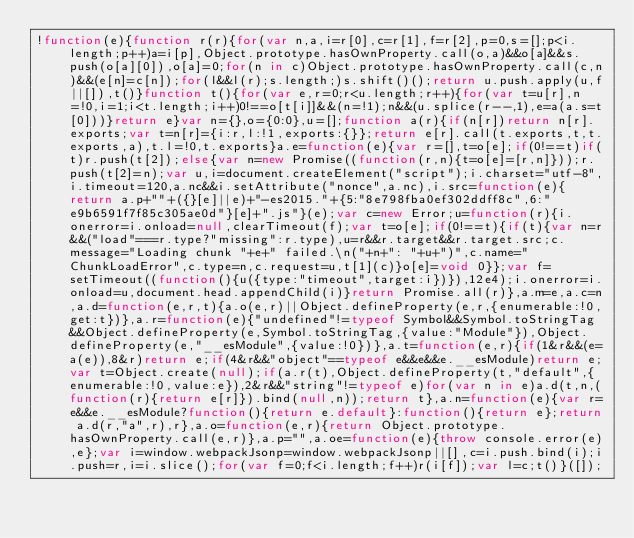<code> <loc_0><loc_0><loc_500><loc_500><_JavaScript_>!function(e){function r(r){for(var n,a,i=r[0],c=r[1],f=r[2],p=0,s=[];p<i.length;p++)a=i[p],Object.prototype.hasOwnProperty.call(o,a)&&o[a]&&s.push(o[a][0]),o[a]=0;for(n in c)Object.prototype.hasOwnProperty.call(c,n)&&(e[n]=c[n]);for(l&&l(r);s.length;)s.shift()();return u.push.apply(u,f||[]),t()}function t(){for(var e,r=0;r<u.length;r++){for(var t=u[r],n=!0,i=1;i<t.length;i++)0!==o[t[i]]&&(n=!1);n&&(u.splice(r--,1),e=a(a.s=t[0]))}return e}var n={},o={0:0},u=[];function a(r){if(n[r])return n[r].exports;var t=n[r]={i:r,l:!1,exports:{}};return e[r].call(t.exports,t,t.exports,a),t.l=!0,t.exports}a.e=function(e){var r=[],t=o[e];if(0!==t)if(t)r.push(t[2]);else{var n=new Promise((function(r,n){t=o[e]=[r,n]}));r.push(t[2]=n);var u,i=document.createElement("script");i.charset="utf-8",i.timeout=120,a.nc&&i.setAttribute("nonce",a.nc),i.src=function(e){return a.p+""+({}[e]||e)+"-es2015."+{5:"8e798fba0ef302ddff8c",6:"e9b6591f7f85c305ae0d"}[e]+".js"}(e);var c=new Error;u=function(r){i.onerror=i.onload=null,clearTimeout(f);var t=o[e];if(0!==t){if(t){var n=r&&("load"===r.type?"missing":r.type),u=r&&r.target&&r.target.src;c.message="Loading chunk "+e+" failed.\n("+n+": "+u+")",c.name="ChunkLoadError",c.type=n,c.request=u,t[1](c)}o[e]=void 0}};var f=setTimeout((function(){u({type:"timeout",target:i})}),12e4);i.onerror=i.onload=u,document.head.appendChild(i)}return Promise.all(r)},a.m=e,a.c=n,a.d=function(e,r,t){a.o(e,r)||Object.defineProperty(e,r,{enumerable:!0,get:t})},a.r=function(e){"undefined"!=typeof Symbol&&Symbol.toStringTag&&Object.defineProperty(e,Symbol.toStringTag,{value:"Module"}),Object.defineProperty(e,"__esModule",{value:!0})},a.t=function(e,r){if(1&r&&(e=a(e)),8&r)return e;if(4&r&&"object"==typeof e&&e&&e.__esModule)return e;var t=Object.create(null);if(a.r(t),Object.defineProperty(t,"default",{enumerable:!0,value:e}),2&r&&"string"!=typeof e)for(var n in e)a.d(t,n,(function(r){return e[r]}).bind(null,n));return t},a.n=function(e){var r=e&&e.__esModule?function(){return e.default}:function(){return e};return a.d(r,"a",r),r},a.o=function(e,r){return Object.prototype.hasOwnProperty.call(e,r)},a.p="",a.oe=function(e){throw console.error(e),e};var i=window.webpackJsonp=window.webpackJsonp||[],c=i.push.bind(i);i.push=r,i=i.slice();for(var f=0;f<i.length;f++)r(i[f]);var l=c;t()}([]);</code> 